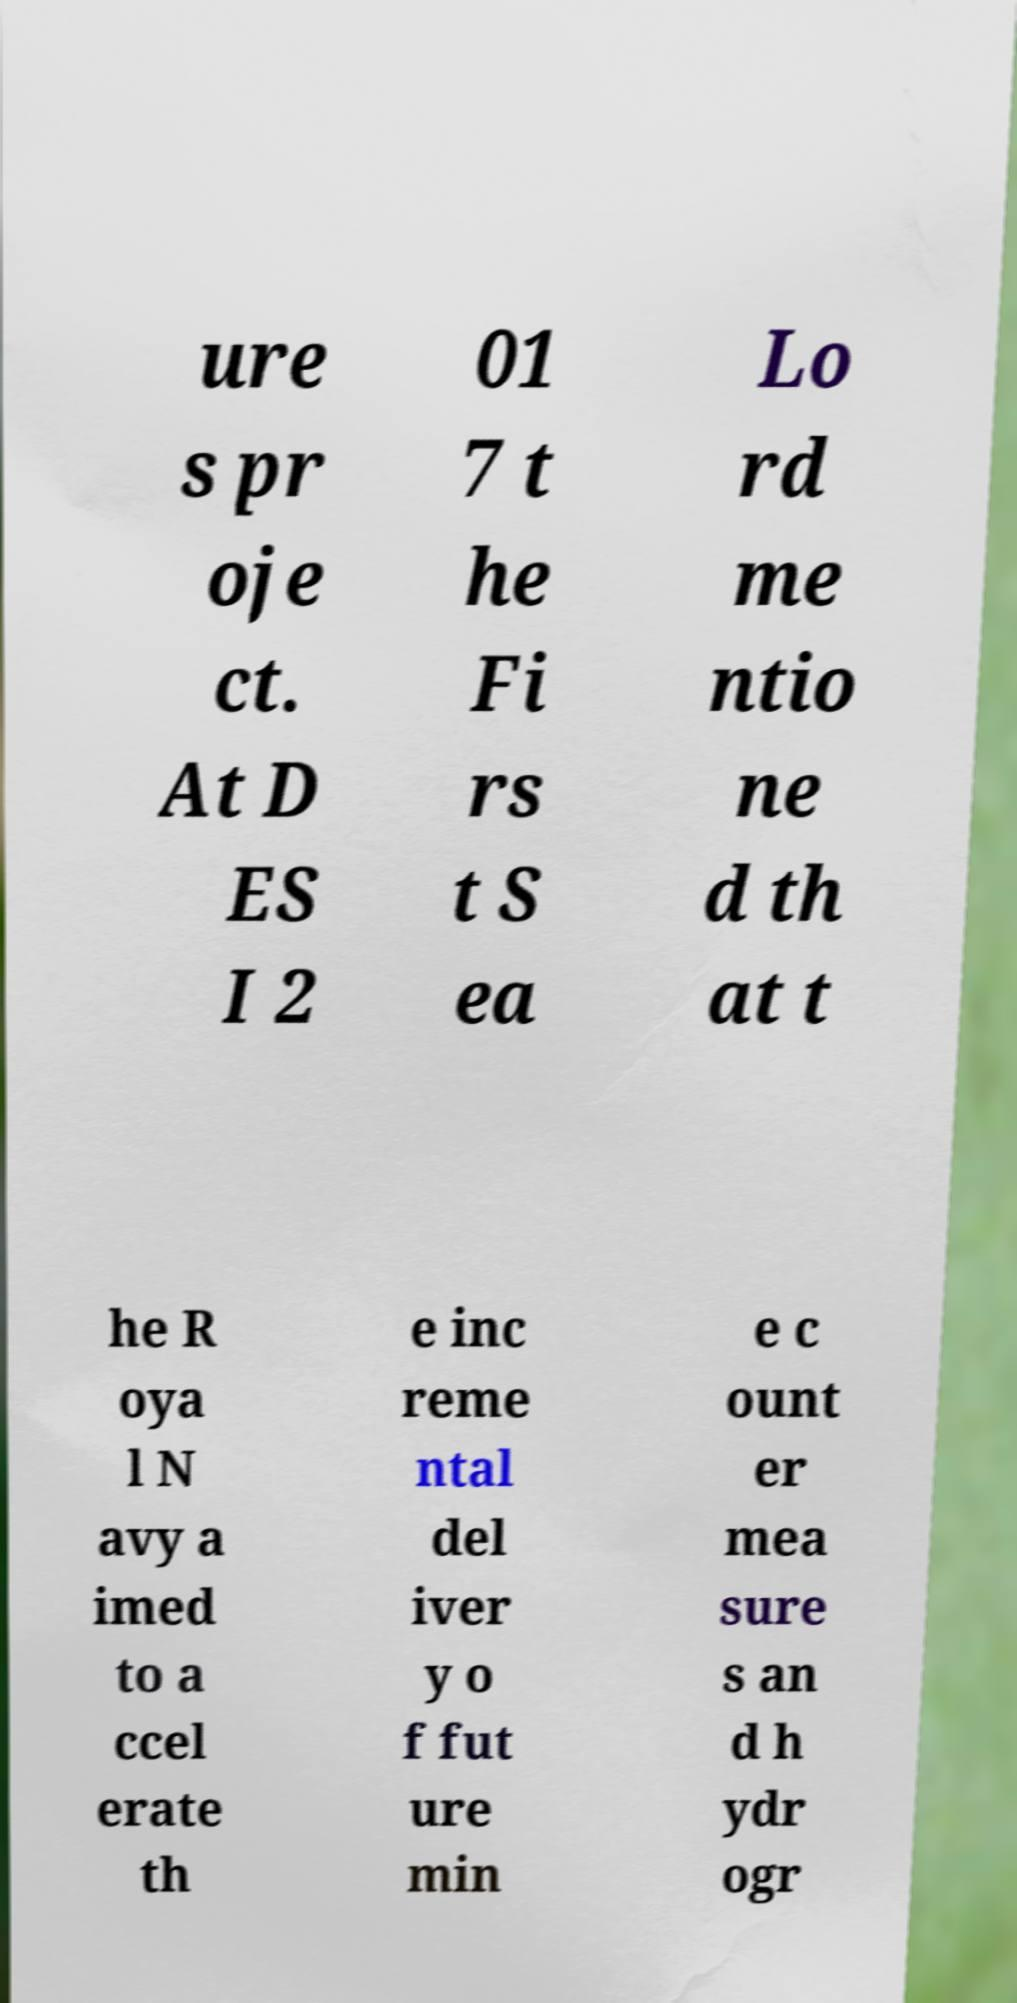Could you assist in decoding the text presented in this image and type it out clearly? ure s pr oje ct. At D ES I 2 01 7 t he Fi rs t S ea Lo rd me ntio ne d th at t he R oya l N avy a imed to a ccel erate th e inc reme ntal del iver y o f fut ure min e c ount er mea sure s an d h ydr ogr 